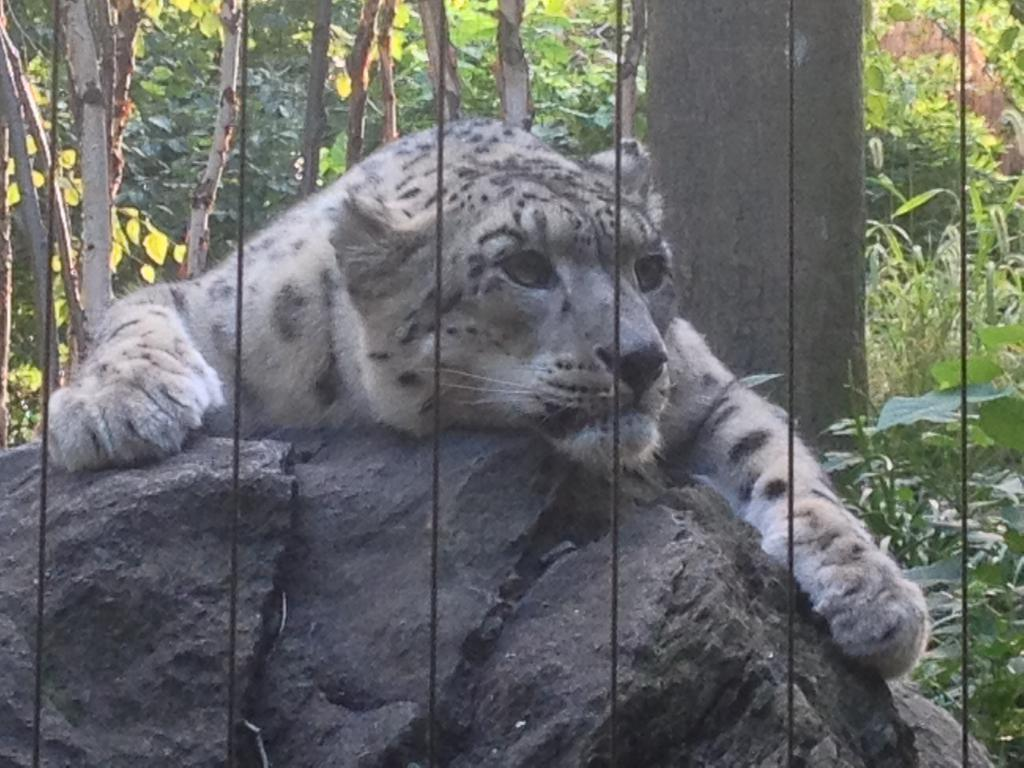What type of animal is in the picture? There is a tiger in the picture. What other objects or features can be seen in the picture? There are rocks in the picture. What can be seen in the background of the picture? There are trees in the background of the picture. What type of bird is perched on the sail in the picture? There is no sail present in the picture, as it features a tiger and rocks with trees in the background. 